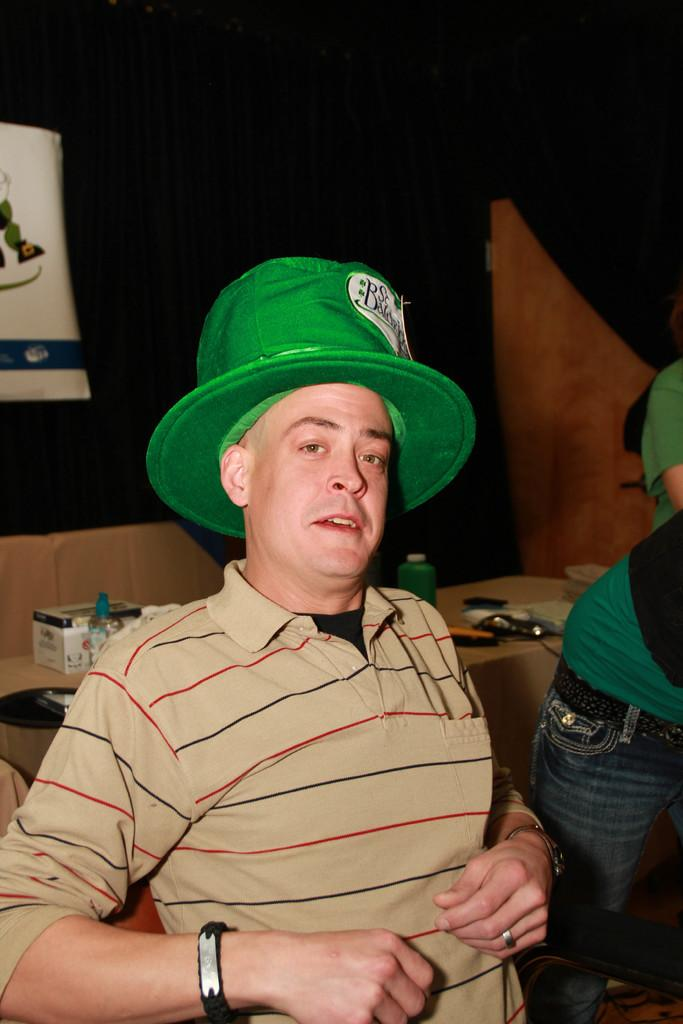What is the main subject of the image? There is a man in the image. Can you describe the man's appearance? The man is wearing a hat. Are there any other people in the image? Yes, there are two other people behind the man. What can be seen in the background of the image? There is a table in the background of the image. What is on the table? There are objects on the table. How does the frog stretch on the table in the image? There is no frog present in the image, so it cannot stretch on the table. What type of quartz can be seen on the man's hat in the image? There is no quartz mentioned or visible on the man's hat in the image. 